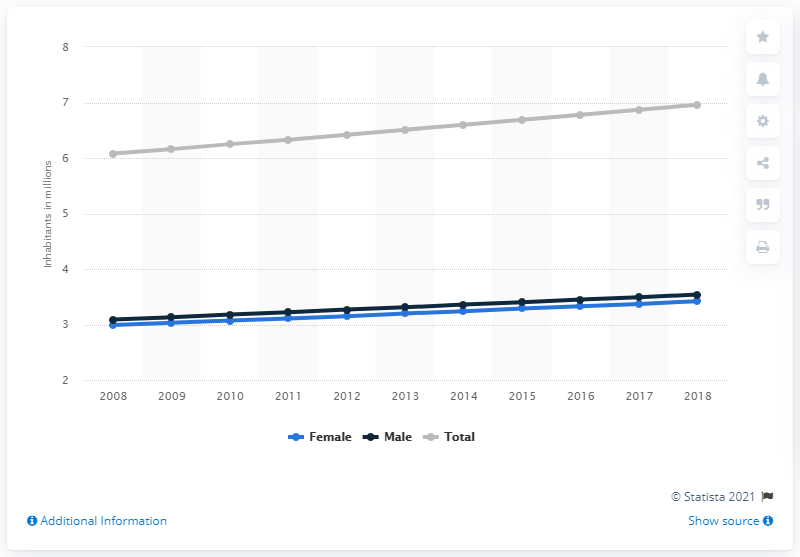Point out several critical features in this image. In 2018, it is estimated that approximately 3.42 million women lived in Paraguay. In 2018, it is estimated that approximately 3.49 million men lived in Paraguay. In 2018, the estimated number of men living in Paraguay was 3.49 million. 